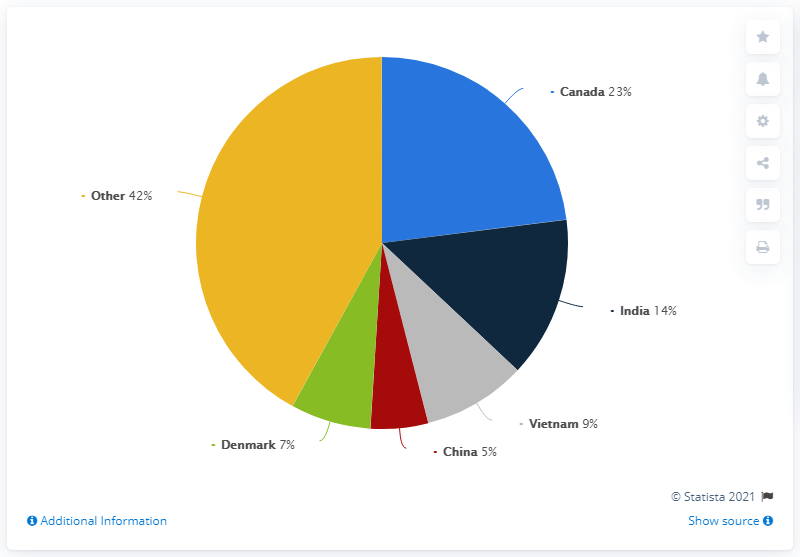Outline some significant characteristics in this image. According to data from 2019, the United States imported a significant percentage of its shrimp from Canada, which accounted for 23% of the total shrimp export volume. By how much more volume does India have than China? 